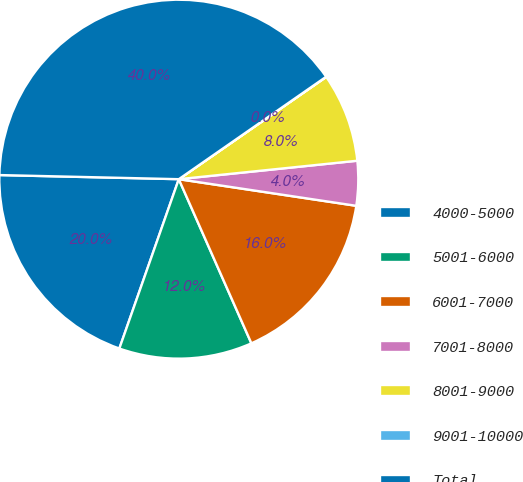Convert chart to OTSL. <chart><loc_0><loc_0><loc_500><loc_500><pie_chart><fcel>4000-5000<fcel>5001-6000<fcel>6001-7000<fcel>7001-8000<fcel>8001-9000<fcel>9001-10000<fcel>Total<nl><fcel>19.99%<fcel>12.0%<fcel>16.0%<fcel>4.01%<fcel>8.01%<fcel>0.02%<fcel>39.96%<nl></chart> 